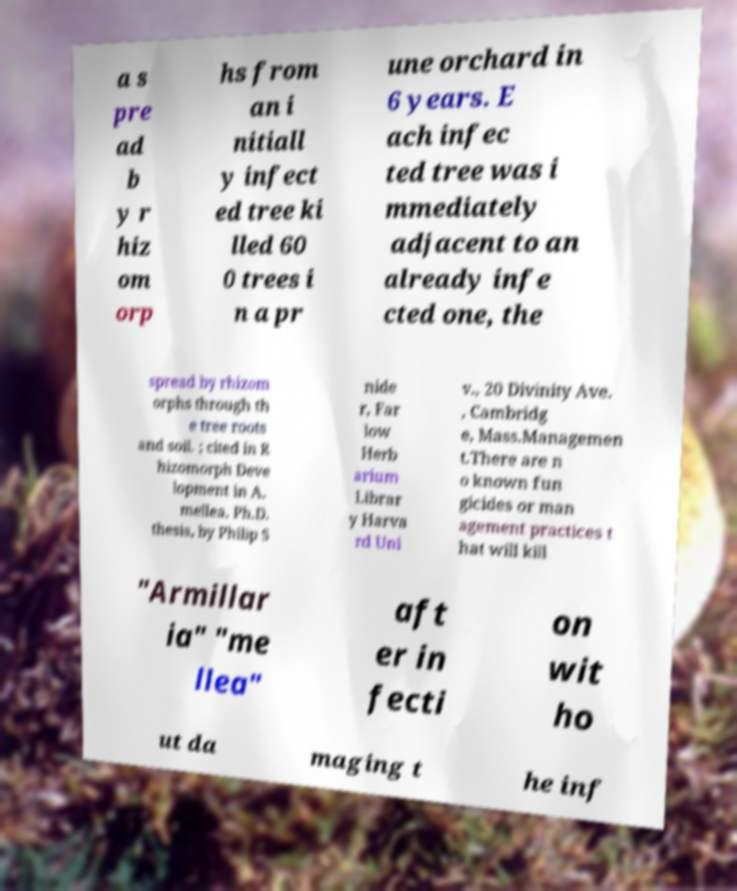Please read and relay the text visible in this image. What does it say? a s pre ad b y r hiz om orp hs from an i nitiall y infect ed tree ki lled 60 0 trees i n a pr une orchard in 6 years. E ach infec ted tree was i mmediately adjacent to an already infe cted one, the spread by rhizom orphs through th e tree roots and soil. ; cited in R hizomorph Deve lopment in A. mellea, Ph.D. thesis, by Philip S nide r, Far low Herb arium Librar y Harva rd Uni v., 20 Divinity Ave. , Cambridg e, Mass.Managemen t.There are n o known fun gicides or man agement practices t hat will kill "Armillar ia" "me llea" aft er in fecti on wit ho ut da maging t he inf 